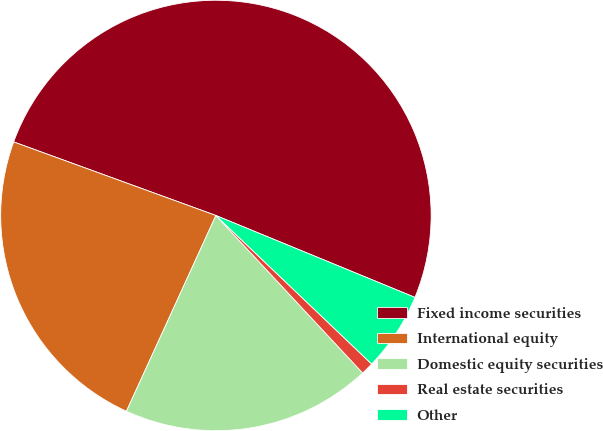Convert chart to OTSL. <chart><loc_0><loc_0><loc_500><loc_500><pie_chart><fcel>Fixed income securities<fcel>International equity<fcel>Domestic equity securities<fcel>Real estate securities<fcel>Other<nl><fcel>50.66%<fcel>23.73%<fcel>18.76%<fcel>0.94%<fcel>5.91%<nl></chart> 